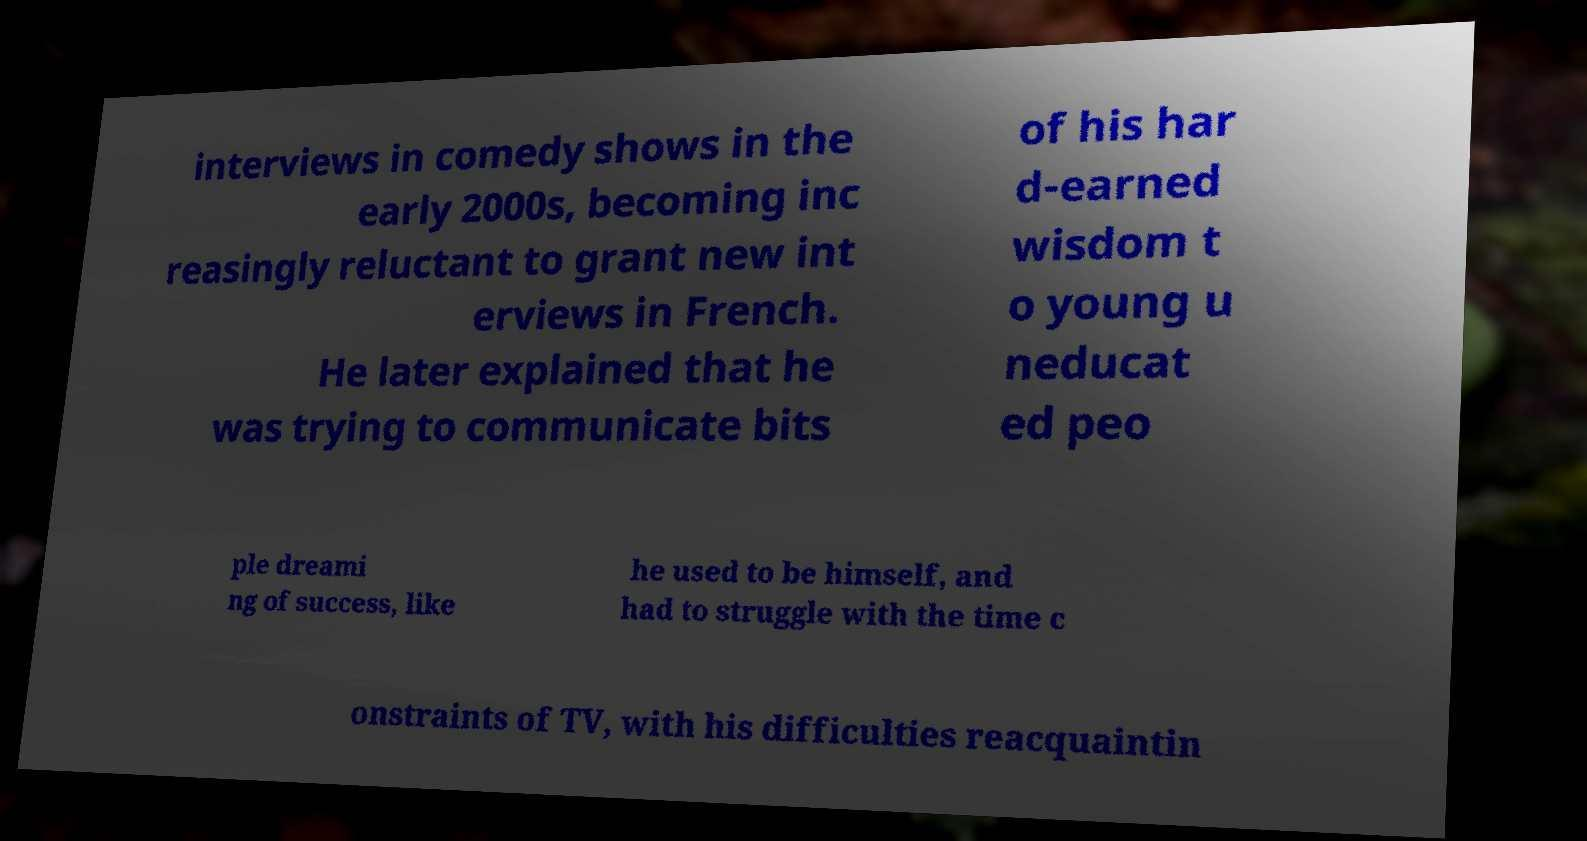I need the written content from this picture converted into text. Can you do that? interviews in comedy shows in the early 2000s, becoming inc reasingly reluctant to grant new int erviews in French. He later explained that he was trying to communicate bits of his har d-earned wisdom t o young u neducat ed peo ple dreami ng of success, like he used to be himself, and had to struggle with the time c onstraints of TV, with his difficulties reacquaintin 